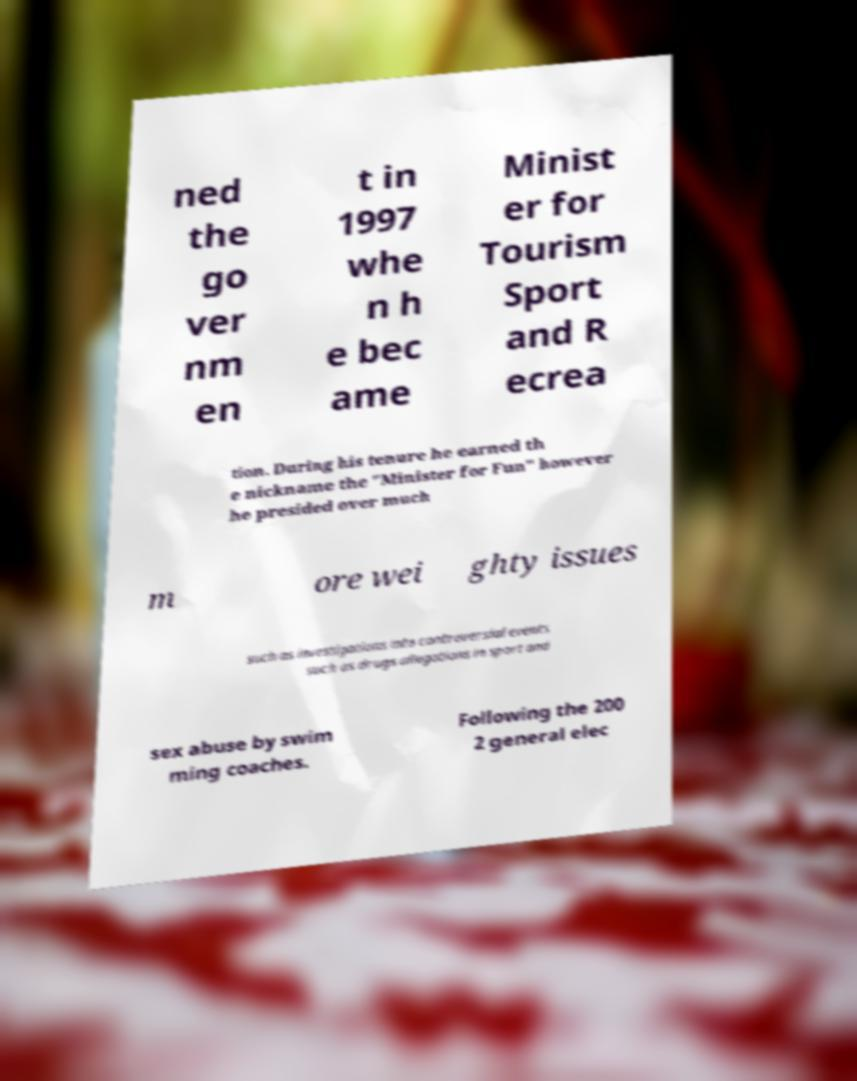Could you assist in decoding the text presented in this image and type it out clearly? ned the go ver nm en t in 1997 whe n h e bec ame Minist er for Tourism Sport and R ecrea tion. During his tenure he earned th e nickname the "Minister for Fun" however he presided over much m ore wei ghty issues such as investigations into controversial events such as drugs allegations in sport and sex abuse by swim ming coaches. Following the 200 2 general elec 